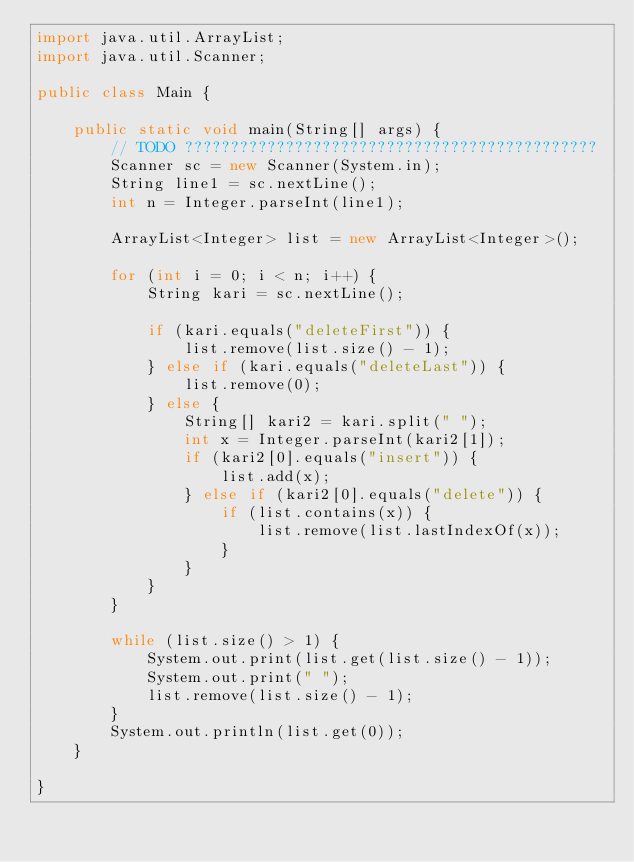<code> <loc_0><loc_0><loc_500><loc_500><_Java_>import java.util.ArrayList;
import java.util.Scanner;

public class Main {

	public static void main(String[] args) {
		// TODO ?????????????????????????????????????????????
		Scanner sc = new Scanner(System.in);
		String line1 = sc.nextLine();
		int n = Integer.parseInt(line1);

		ArrayList<Integer> list = new ArrayList<Integer>();

		for (int i = 0; i < n; i++) {
			String kari = sc.nextLine();

			if (kari.equals("deleteFirst")) {
				list.remove(list.size() - 1);
			} else if (kari.equals("deleteLast")) {
				list.remove(0);
			} else {
				String[] kari2 = kari.split(" ");
				int x = Integer.parseInt(kari2[1]);
				if (kari2[0].equals("insert")) {
					list.add(x);
				} else if (kari2[0].equals("delete")) {
					if (list.contains(x)) {
						list.remove(list.lastIndexOf(x));
					}
				}
			}
		}

		while (list.size() > 1) {
			System.out.print(list.get(list.size() - 1));
			System.out.print(" ");
			list.remove(list.size() - 1);
		}
		System.out.println(list.get(0));
	}

}</code> 